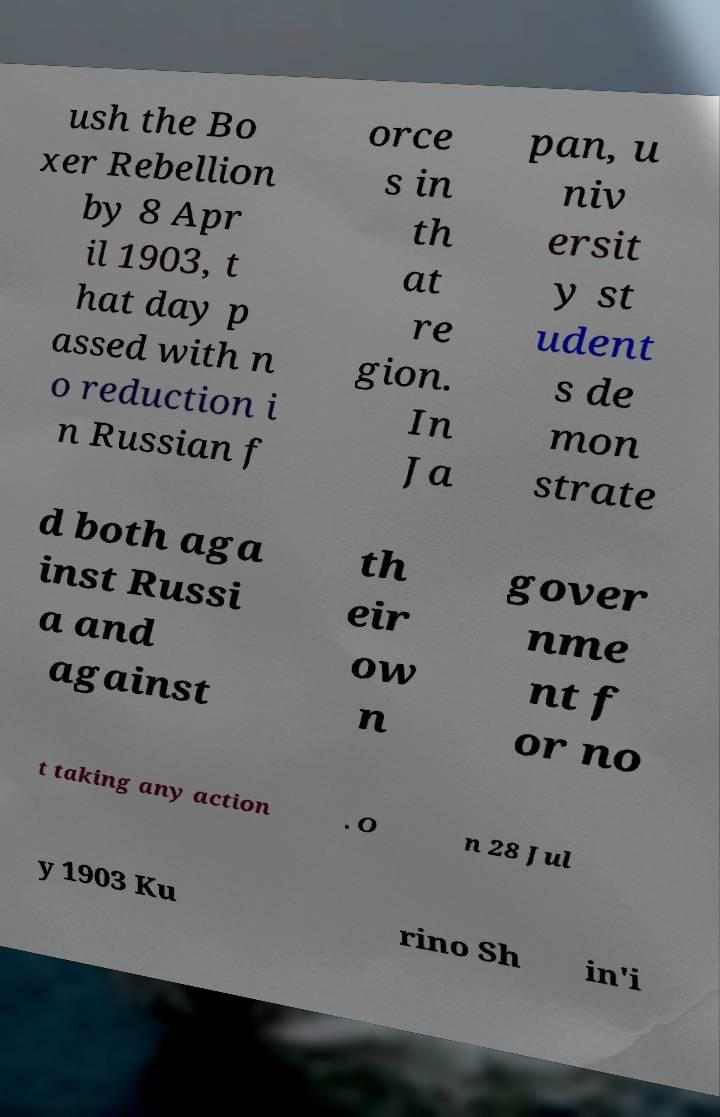What messages or text are displayed in this image? I need them in a readable, typed format. ush the Bo xer Rebellion by 8 Apr il 1903, t hat day p assed with n o reduction i n Russian f orce s in th at re gion. In Ja pan, u niv ersit y st udent s de mon strate d both aga inst Russi a and against th eir ow n gover nme nt f or no t taking any action . O n 28 Jul y 1903 Ku rino Sh in'i 